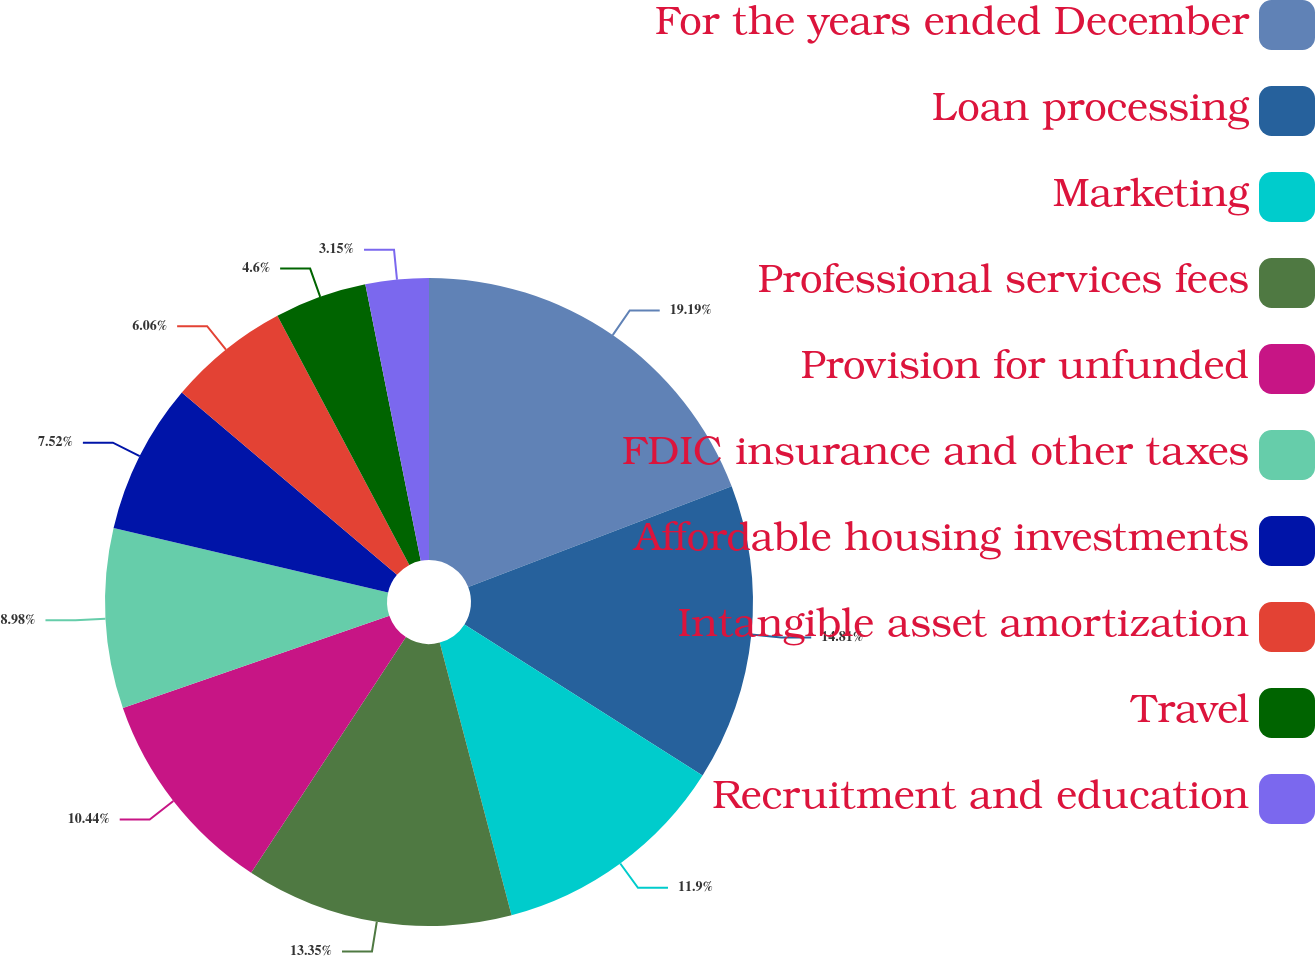Convert chart to OTSL. <chart><loc_0><loc_0><loc_500><loc_500><pie_chart><fcel>For the years ended December<fcel>Loan processing<fcel>Marketing<fcel>Professional services fees<fcel>Provision for unfunded<fcel>FDIC insurance and other taxes<fcel>Affordable housing investments<fcel>Intangible asset amortization<fcel>Travel<fcel>Recruitment and education<nl><fcel>19.19%<fcel>14.81%<fcel>11.9%<fcel>13.35%<fcel>10.44%<fcel>8.98%<fcel>7.52%<fcel>6.06%<fcel>4.6%<fcel>3.15%<nl></chart> 